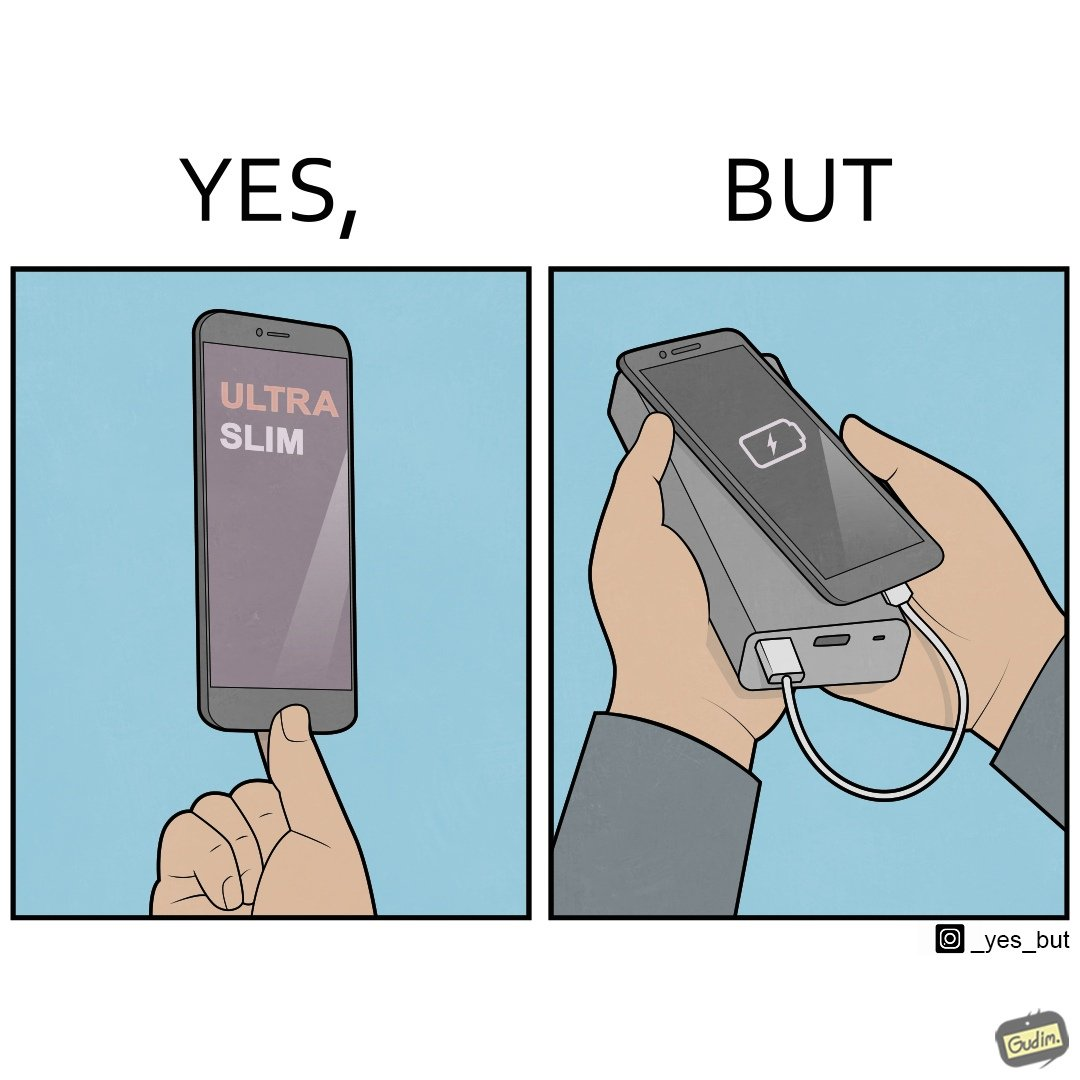Would you classify this image as satirical? Yes, this image is satirical. 